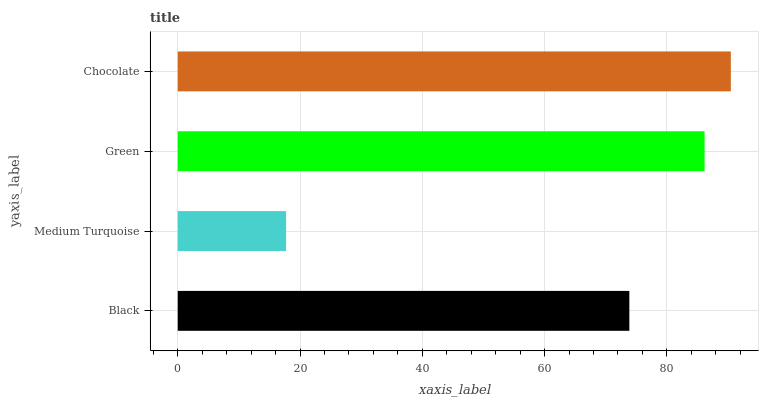Is Medium Turquoise the minimum?
Answer yes or no. Yes. Is Chocolate the maximum?
Answer yes or no. Yes. Is Green the minimum?
Answer yes or no. No. Is Green the maximum?
Answer yes or no. No. Is Green greater than Medium Turquoise?
Answer yes or no. Yes. Is Medium Turquoise less than Green?
Answer yes or no. Yes. Is Medium Turquoise greater than Green?
Answer yes or no. No. Is Green less than Medium Turquoise?
Answer yes or no. No. Is Green the high median?
Answer yes or no. Yes. Is Black the low median?
Answer yes or no. Yes. Is Black the high median?
Answer yes or no. No. Is Green the low median?
Answer yes or no. No. 